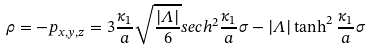Convert formula to latex. <formula><loc_0><loc_0><loc_500><loc_500>\rho = - p _ { x , y , z } = 3 \frac { \kappa _ { 1 } } { a } \sqrt { \frac { | \Lambda | } { 6 } } s e c h ^ { 2 } \frac { \kappa _ { 1 } } { a } \sigma - | \Lambda | \tanh ^ { 2 } \frac { \kappa _ { 1 } } { a } \sigma</formula> 